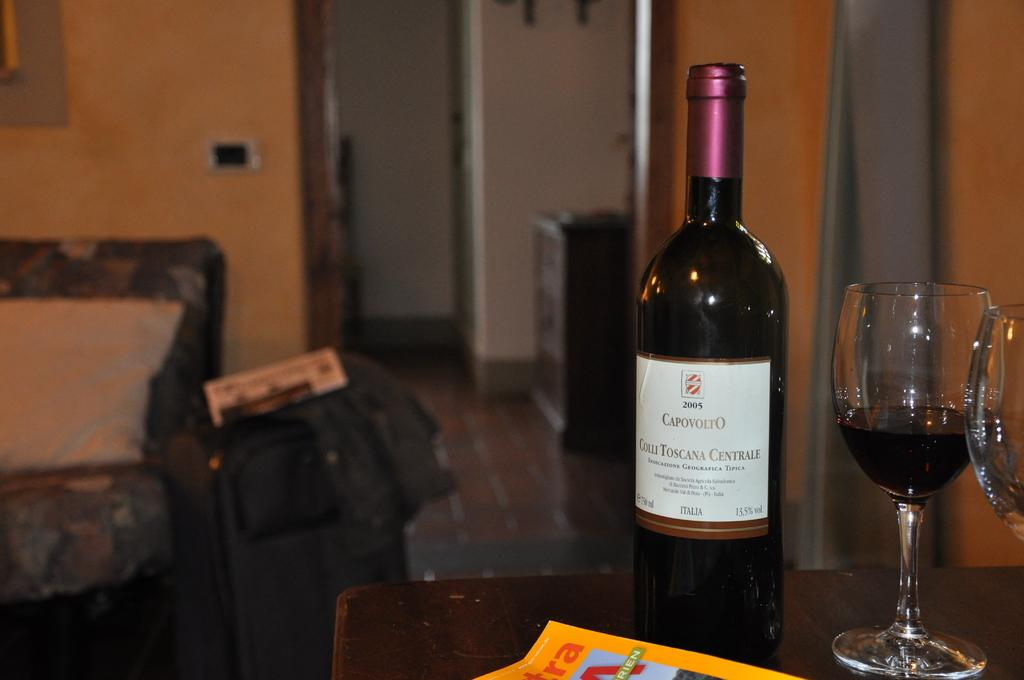What type of furniture is located on the left side of the image? There is a sofa on the left side of the image. What can be seen in the background of the image? There is a wall in the background of the image. What is at the bottom of the image? There is a table at the bottom of the image. What is on the table? There is a bottle and glasses on the table. Can you tell me how many pigs are sitting on the sofa in the image? There are no pigs present in the image; it features a sofa, a wall, a table, a bottle, and glasses. How many oranges are on the table in the image? There are no oranges present in the image; it features a bottle and glasses on the table. 